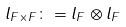Convert formula to latex. <formula><loc_0><loc_0><loc_500><loc_500>l _ { F \times F } \colon = l _ { F } \otimes l _ { F }</formula> 